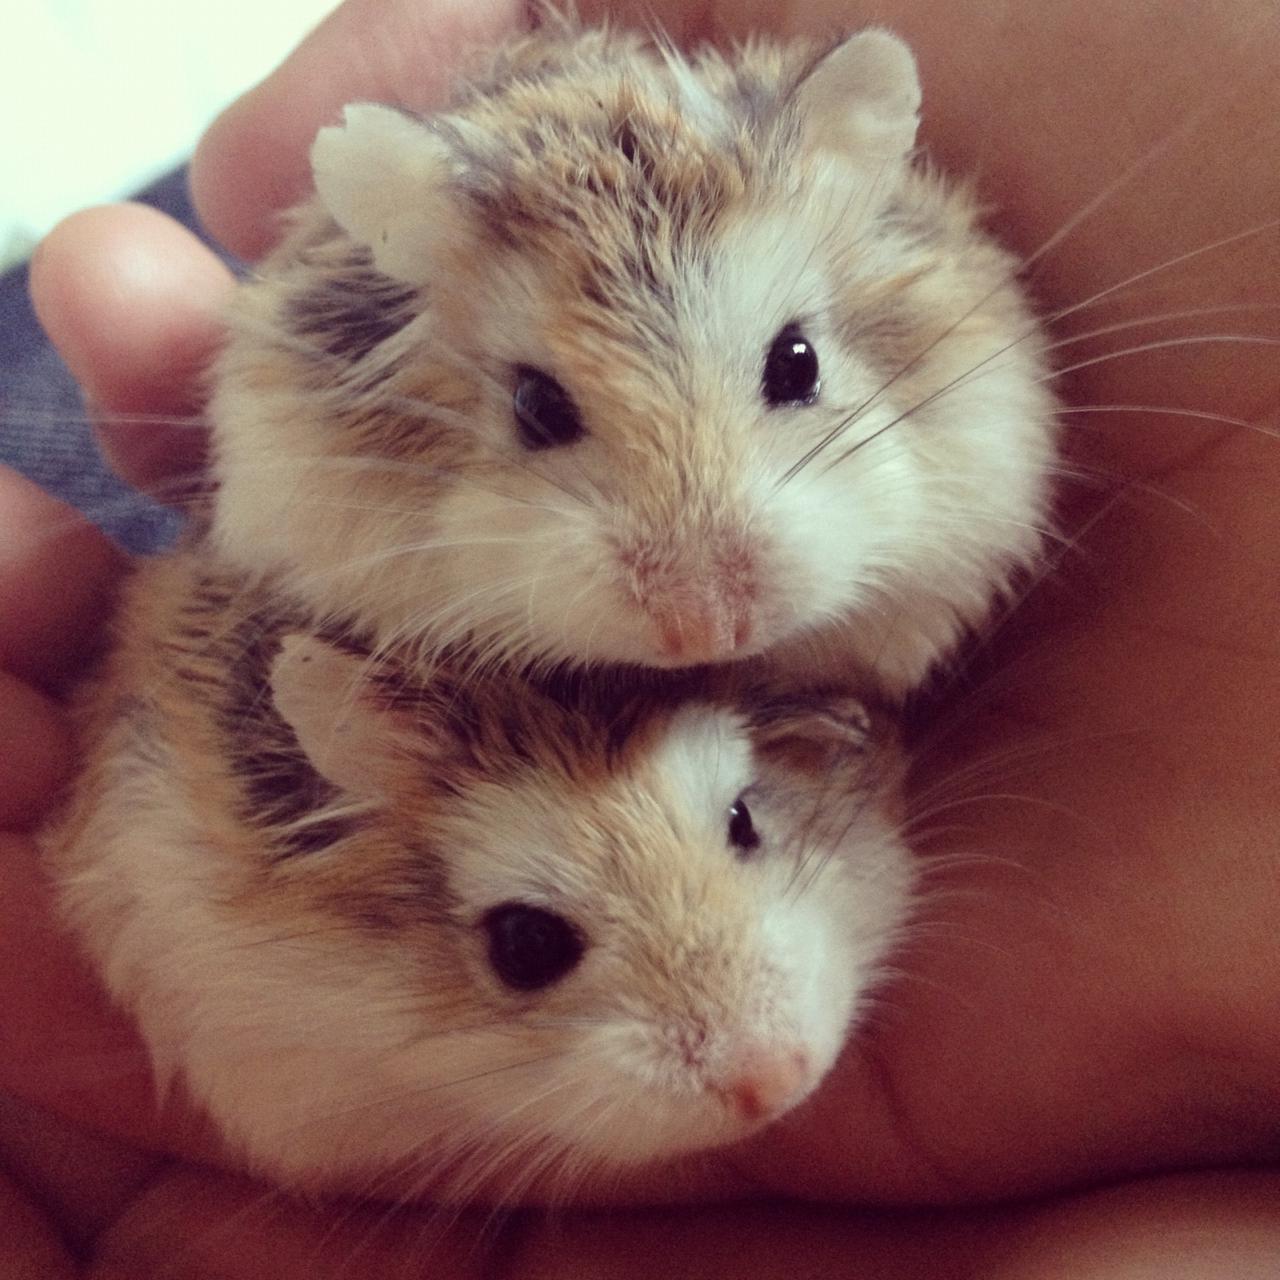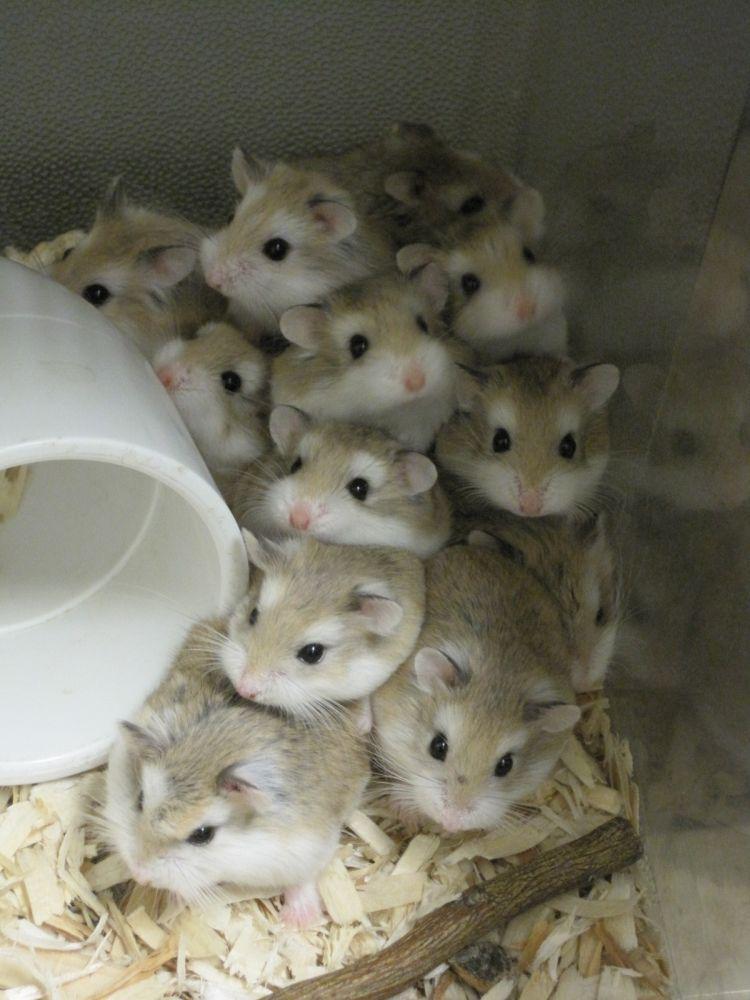The first image is the image on the left, the second image is the image on the right. Considering the images on both sides, is "At least one mouse has it's eyes wide open and and least one mouse is sleeping." valid? Answer yes or no. No. The first image is the image on the left, the second image is the image on the right. Considering the images on both sides, is "An image contains at least one blackish newborn rodent." valid? Answer yes or no. No. 